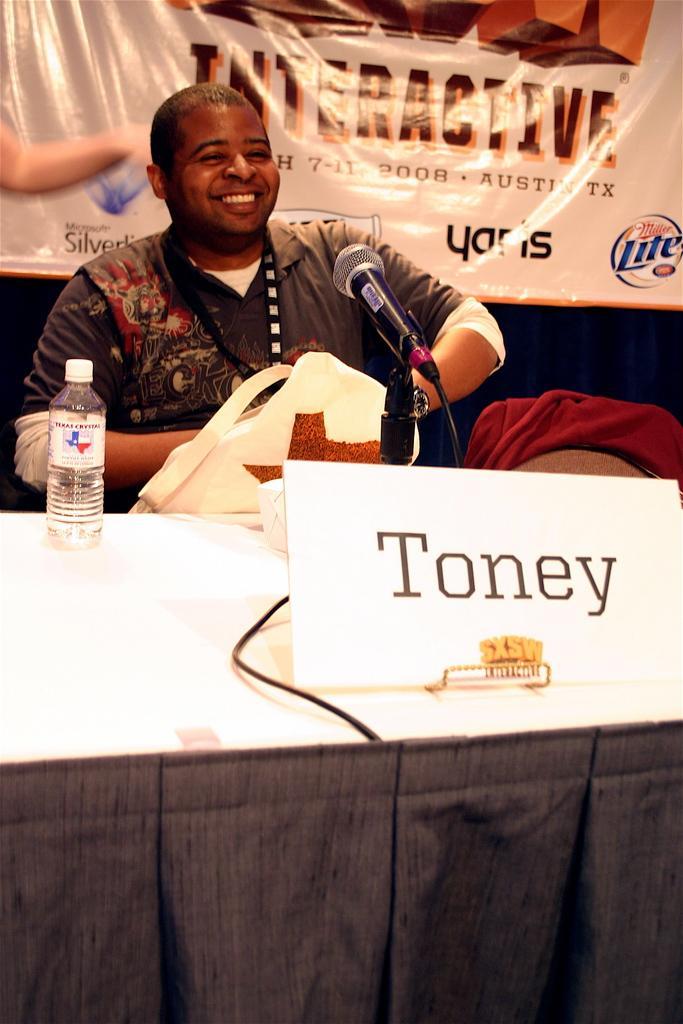Please provide a concise description of this image. In this image we can see a man is sitting and smiling. In front of him, table is present. On the table, we can see name plate, mic, wire and bottle. In the background, there is a poster with some text written on it. Beside the man, we can see a chair. On the chair, there is a cloth and the man is holding one white color object in his hands. 